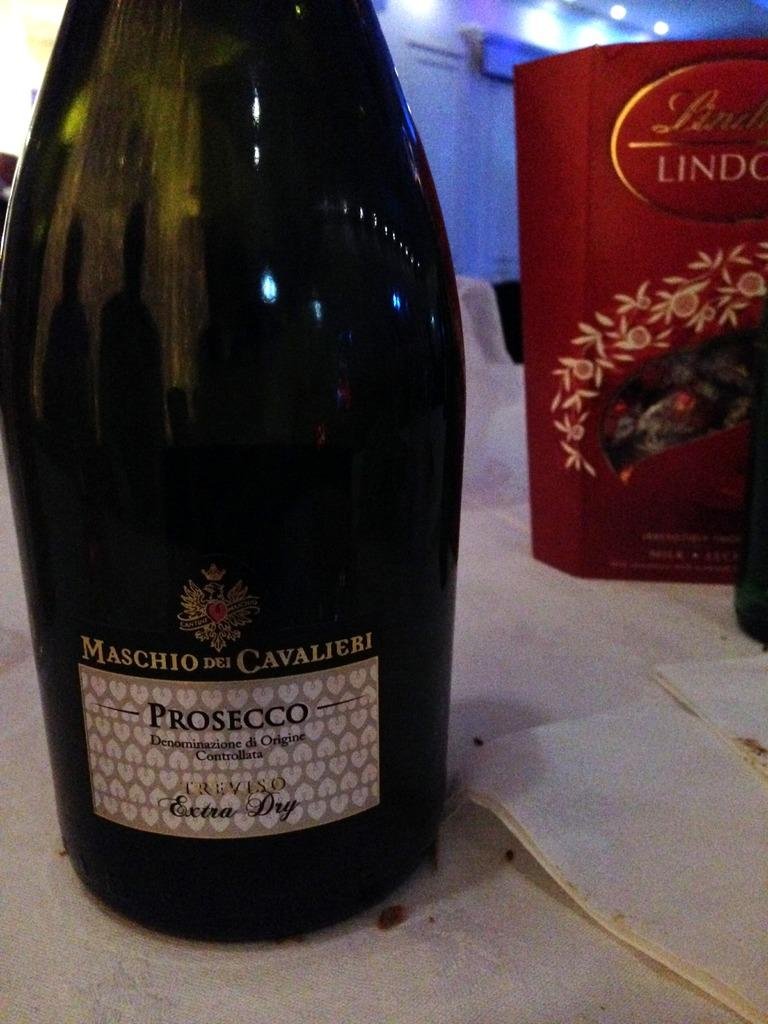Provide a one-sentence caption for the provided image. A large wine bottle labeled Maschio Dei Cavalieri sits on a table. 